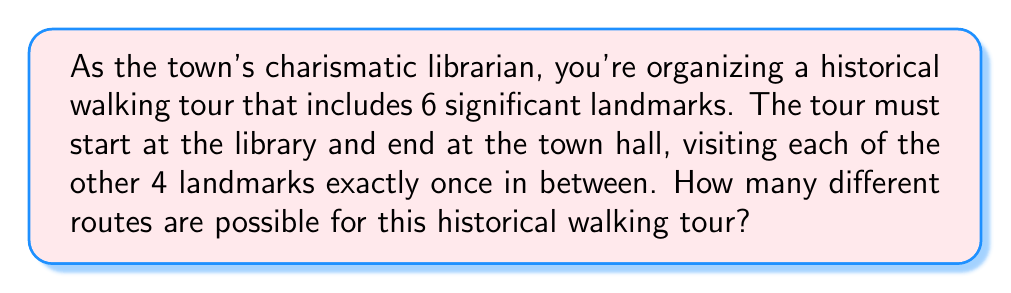Can you solve this math problem? Let's approach this step-by-step:

1) We have 6 landmarks in total: the library (start), town hall (end), and 4 other landmarks.

2) The start and end points are fixed, so we only need to determine the number of ways to arrange the other 4 landmarks.

3) This is a permutation problem. We need to find the number of ways to arrange 4 distinct objects.

4) The formula for permutations of n distinct objects is:

   $$P(n) = n!$$

5) In this case, n = 4, so we calculate:

   $$P(4) = 4!$$

6) Let's expand this:

   $$4! = 4 \times 3 \times 2 \times 1 = 24$$

7) Therefore, there are 24 different ways to arrange the 4 landmarks between the library and town hall.

This means there are 24 possible routes for the historical walking tour.
Answer: 24 